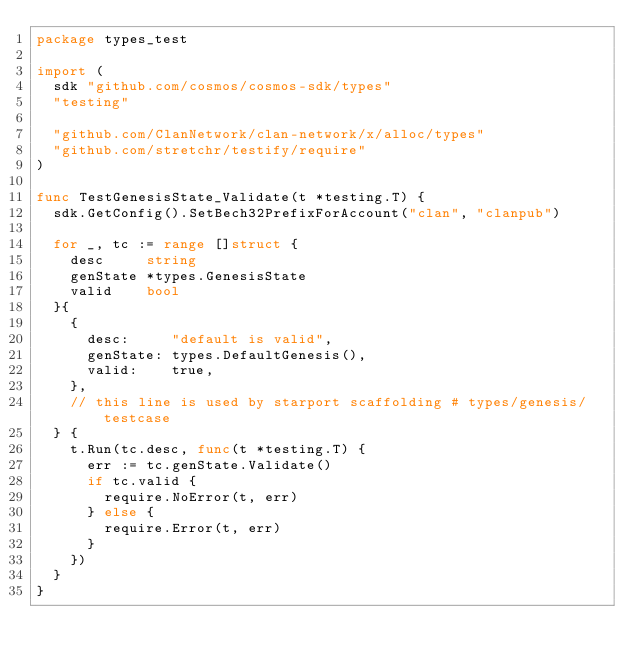<code> <loc_0><loc_0><loc_500><loc_500><_Go_>package types_test

import (
	sdk "github.com/cosmos/cosmos-sdk/types"
	"testing"

	"github.com/ClanNetwork/clan-network/x/alloc/types"
	"github.com/stretchr/testify/require"
)

func TestGenesisState_Validate(t *testing.T) {
	sdk.GetConfig().SetBech32PrefixForAccount("clan", "clanpub")

	for _, tc := range []struct {
		desc     string
		genState *types.GenesisState
		valid    bool
	}{
		{
			desc:     "default is valid",
			genState: types.DefaultGenesis(),
			valid:    true,
		},
		// this line is used by starport scaffolding # types/genesis/testcase
	} {
		t.Run(tc.desc, func(t *testing.T) {
			err := tc.genState.Validate()
			if tc.valid {
				require.NoError(t, err)
			} else {
				require.Error(t, err)
			}
		})
	}
}
</code> 